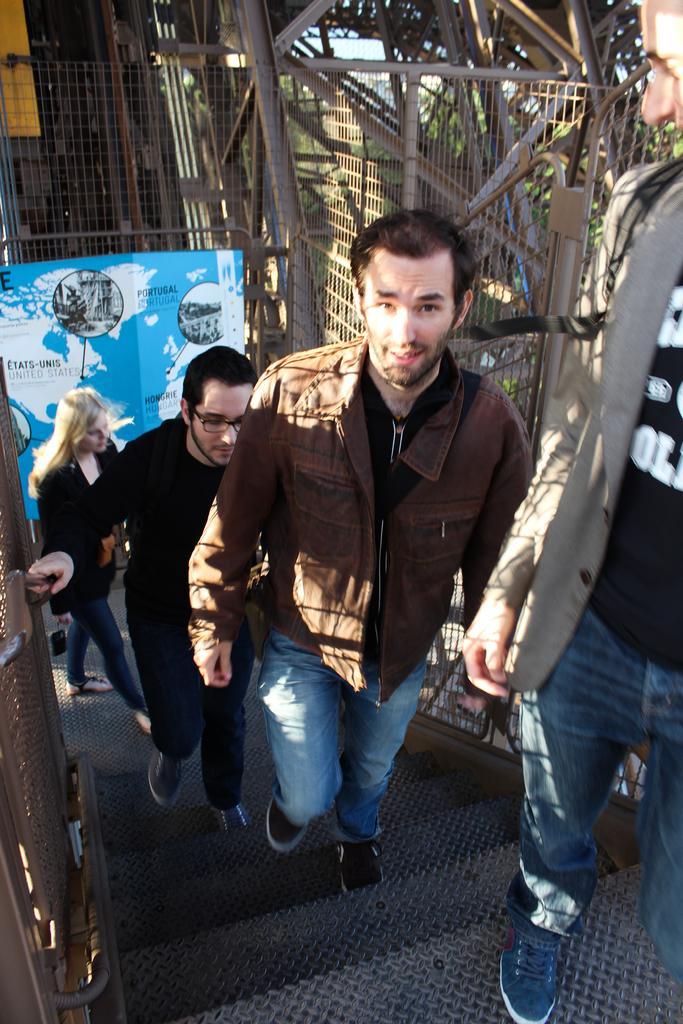In one or two sentences, can you explain what this image depicts? In this image we can see these people are climbing up the stairs. Here we can see the banner, the fence and trees in the background. 